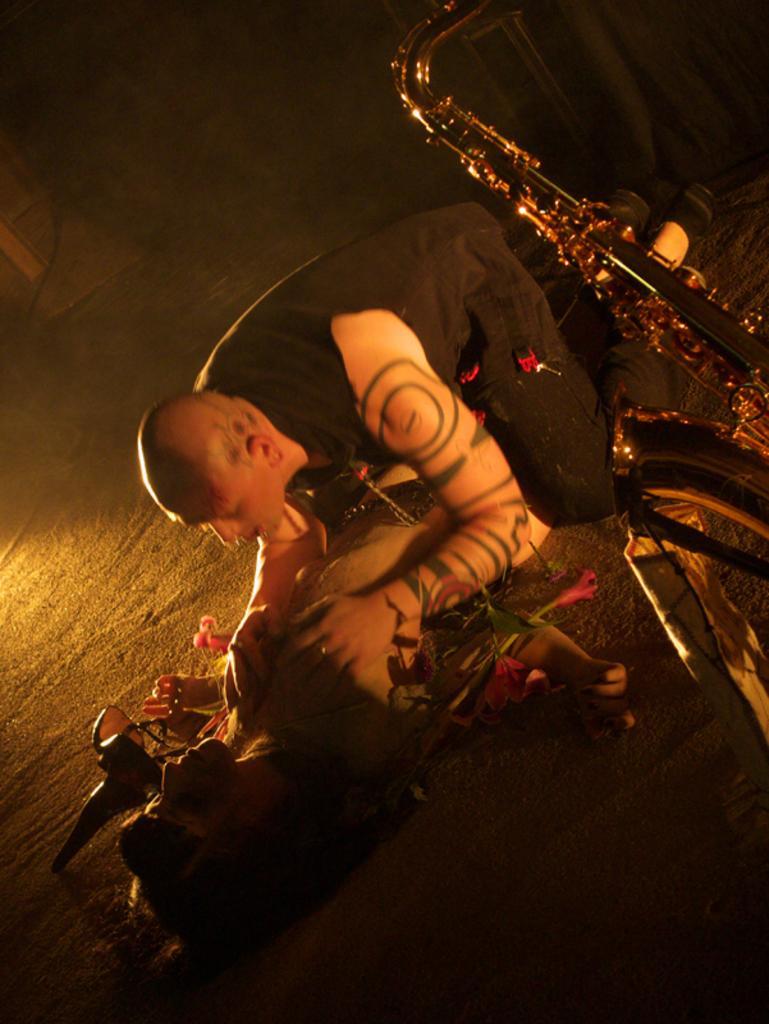Please provide a concise description of this image. In this image there are two people, one is lying on the floor and the other on above the person and there is a musical instrument. 